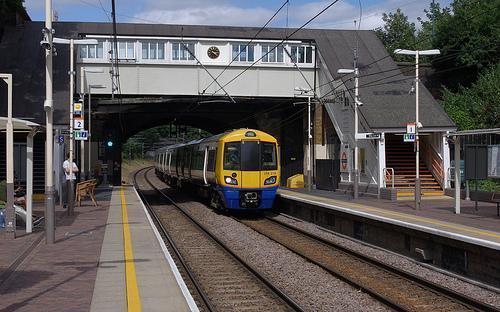How many trains are there?
Give a very brief answer. 1. How many sets of tracks are there?
Give a very brief answer. 2. How many headlights does the train have?
Give a very brief answer. 2. How many tracks are visible?
Give a very brief answer. 2. How many tracks are there?
Give a very brief answer. 2. How many stories does the building have?
Give a very brief answer. 2. How many light does the train have?
Give a very brief answer. 2. How many colors were used to paint the front of the train?
Give a very brief answer. 2. 